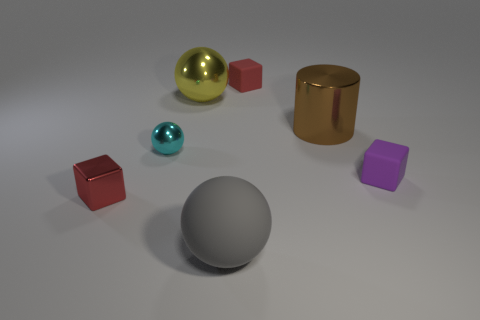What is the shape of the rubber thing that is behind the large gray matte object and to the left of the brown cylinder?
Provide a succinct answer. Cube. What number of purple rubber things are the same shape as the big brown metallic object?
Offer a terse response. 0. What size is the sphere that is the same material as the small purple object?
Provide a short and direct response. Large. Are there more small blue rubber cylinders than small balls?
Your answer should be compact. No. There is a shiny object to the left of the small cyan ball; what color is it?
Offer a very short reply. Red. How big is the rubber object that is both in front of the cyan object and behind the tiny red metallic cube?
Your answer should be compact. Small. What number of brown shiny objects have the same size as the red matte cube?
Provide a succinct answer. 0. What material is the other large thing that is the same shape as the large gray matte thing?
Provide a short and direct response. Metal. Do the large gray thing and the large yellow thing have the same shape?
Keep it short and to the point. Yes. How many big gray matte things are right of the big yellow ball?
Your answer should be very brief. 1. 